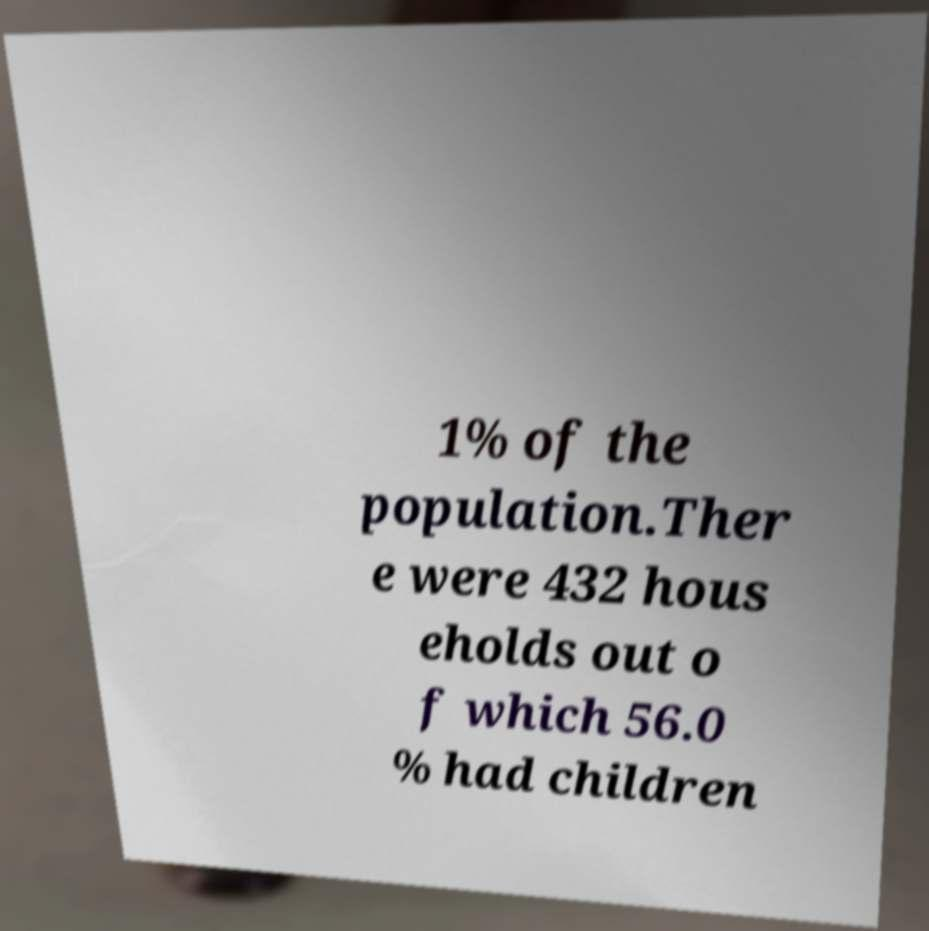I need the written content from this picture converted into text. Can you do that? 1% of the population.Ther e were 432 hous eholds out o f which 56.0 % had children 